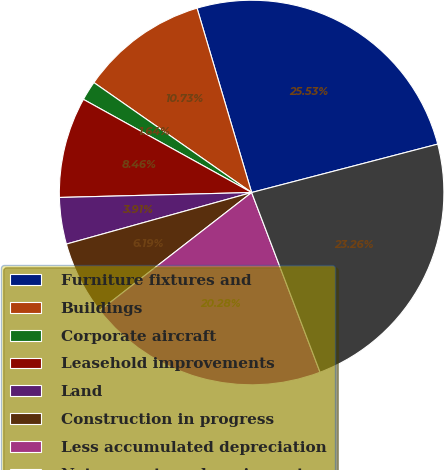Convert chart to OTSL. <chart><loc_0><loc_0><loc_500><loc_500><pie_chart><fcel>Furniture fixtures and<fcel>Buildings<fcel>Corporate aircraft<fcel>Leasehold improvements<fcel>Land<fcel>Construction in progress<fcel>Less accumulated depreciation<fcel>Net property and equipment<nl><fcel>25.53%<fcel>10.73%<fcel>1.64%<fcel>8.46%<fcel>3.91%<fcel>6.19%<fcel>20.28%<fcel>23.26%<nl></chart> 